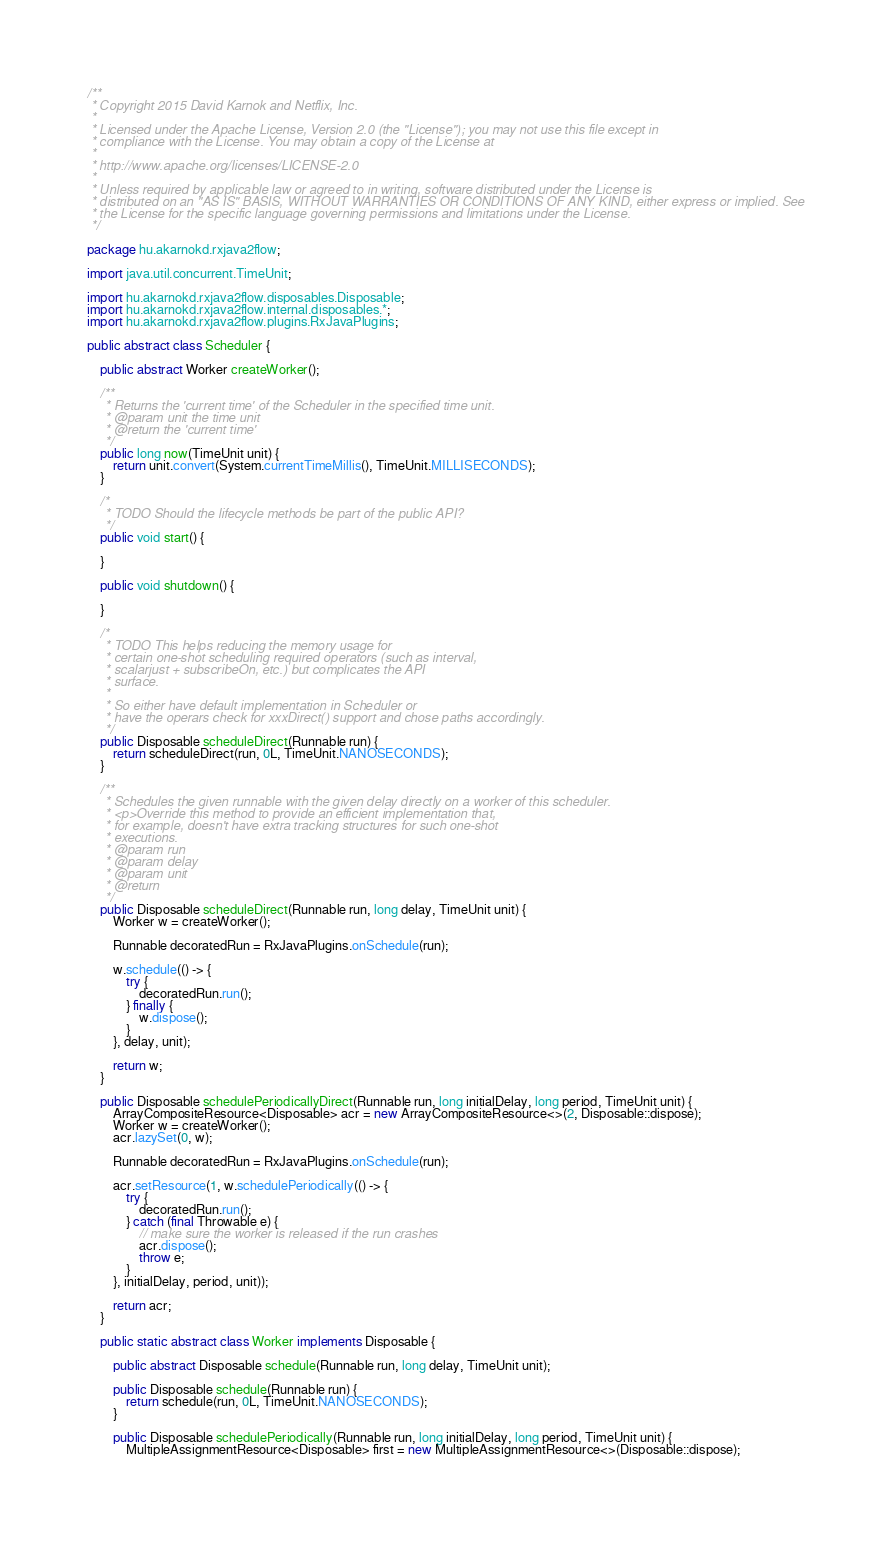<code> <loc_0><loc_0><loc_500><loc_500><_Java_>/**
 * Copyright 2015 David Karnok and Netflix, Inc.
 * 
 * Licensed under the Apache License, Version 2.0 (the "License"); you may not use this file except in
 * compliance with the License. You may obtain a copy of the License at
 * 
 * http://www.apache.org/licenses/LICENSE-2.0
 * 
 * Unless required by applicable law or agreed to in writing, software distributed under the License is
 * distributed on an "AS IS" BASIS, WITHOUT WARRANTIES OR CONDITIONS OF ANY KIND, either express or implied. See
 * the License for the specific language governing permissions and limitations under the License.
 */

package hu.akarnokd.rxjava2flow;

import java.util.concurrent.TimeUnit;

import hu.akarnokd.rxjava2flow.disposables.Disposable;
import hu.akarnokd.rxjava2flow.internal.disposables.*;
import hu.akarnokd.rxjava2flow.plugins.RxJavaPlugins;

public abstract class Scheduler {
    
    public abstract Worker createWorker();

    /**
     * Returns the 'current time' of the Scheduler in the specified time unit.
     * @param unit the time unit
     * @return the 'current time'
     */
    public long now(TimeUnit unit) {
        return unit.convert(System.currentTimeMillis(), TimeUnit.MILLISECONDS);
    }

    /*
     * TODO Should the lifecycle methods be part of the public API?
     */
    public void start() {
        
    }
    
    public void shutdown() {
        
    }
    
    /*
     * TODO This helps reducing the memory usage for 
     * certain one-shot scheduling required operators (such as interval,
     * scalarjust + subscribeOn, etc.) but complicates the API
     * surface.
     * 
     * So either have default implementation in Scheduler or
     * have the operars check for xxxDirect() support and chose paths accordingly.
     */
    public Disposable scheduleDirect(Runnable run) {
        return scheduleDirect(run, 0L, TimeUnit.NANOSECONDS);
    }

    /**
     * Schedules the given runnable with the given delay directly on a worker of this scheduler.
     * <p>Override this method to provide an efficient implementation that,
     * for example, doesn't have extra tracking structures for such one-shot
     * executions.
     * @param run
     * @param delay
     * @param unit
     * @return
     */
    public Disposable scheduleDirect(Runnable run, long delay, TimeUnit unit) {
        Worker w = createWorker();
        
        Runnable decoratedRun = RxJavaPlugins.onSchedule(run);
        
        w.schedule(() -> {
            try {
                decoratedRun.run();
            } finally {
                w.dispose();
            }
        }, delay, unit);
        
        return w;
    }
    
    public Disposable schedulePeriodicallyDirect(Runnable run, long initialDelay, long period, TimeUnit unit) {
        ArrayCompositeResource<Disposable> acr = new ArrayCompositeResource<>(2, Disposable::dispose);
        Worker w = createWorker();
        acr.lazySet(0, w);
        
        Runnable decoratedRun = RxJavaPlugins.onSchedule(run);
        
        acr.setResource(1, w.schedulePeriodically(() -> {
            try {
                decoratedRun.run();
            } catch (final Throwable e) {
                // make sure the worker is released if the run crashes
                acr.dispose();
                throw e;
            }
        }, initialDelay, period, unit));
        
        return acr;
    }

    public static abstract class Worker implements Disposable {

        public abstract Disposable schedule(Runnable run, long delay, TimeUnit unit);

        public Disposable schedule(Runnable run) {
            return schedule(run, 0L, TimeUnit.NANOSECONDS);
        }
        
        public Disposable schedulePeriodically(Runnable run, long initialDelay, long period, TimeUnit unit) {
            MultipleAssignmentResource<Disposable> first = new MultipleAssignmentResource<>(Disposable::dispose);
</code> 